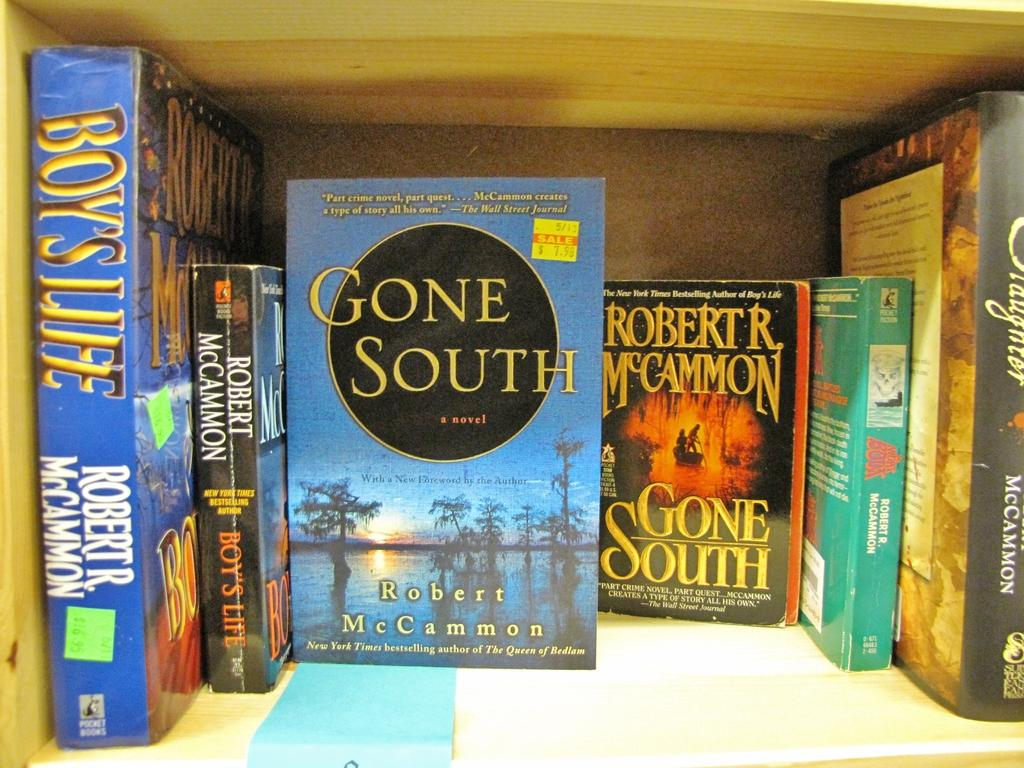What is the main subject of the image? The main subject of the image is books. Where are the books located in the image? The books are in the center of the image. What type of card game is being played on the playground in the image? There is no playground or card game present in the image; it only features books in the center. 